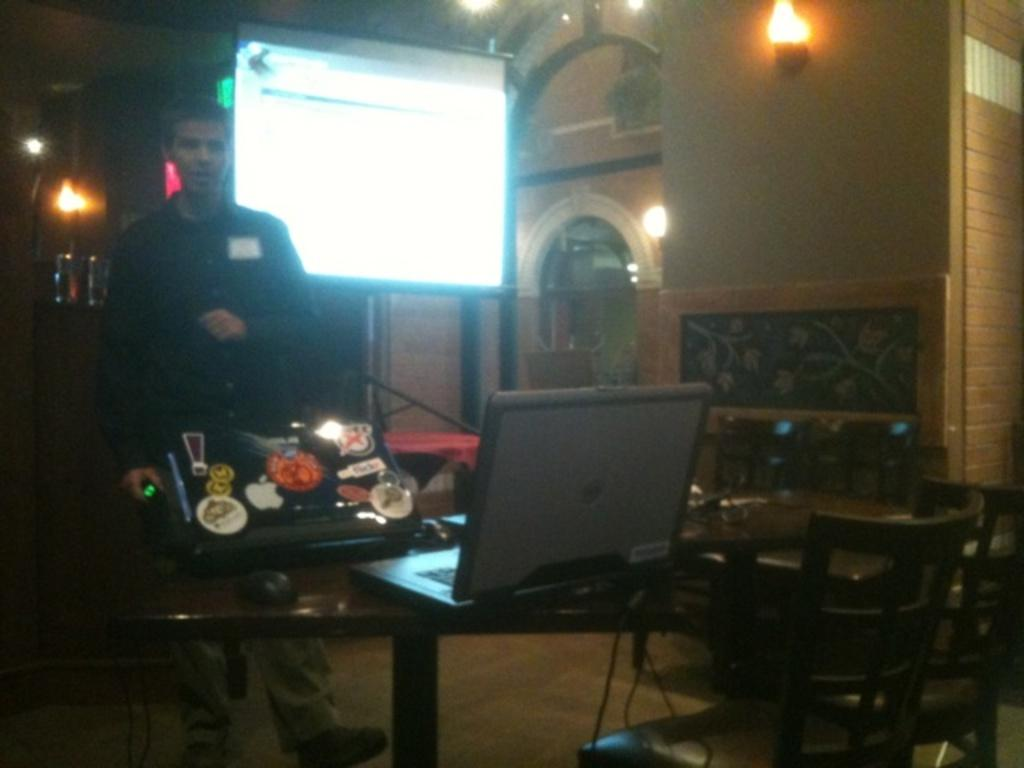What is the main subject in the image? There is a man standing in the image. What is located near the man? There is a table in the image. What object is on the table? There is a laptop on the table. What type of furniture is present in the image? There are chairs in the image. What type of vase can be seen on the laptop in the image? There is no vase present on the laptop in the image. What statement is being made by the man in the image? The image does not provide any information about a statement being made by the man. 